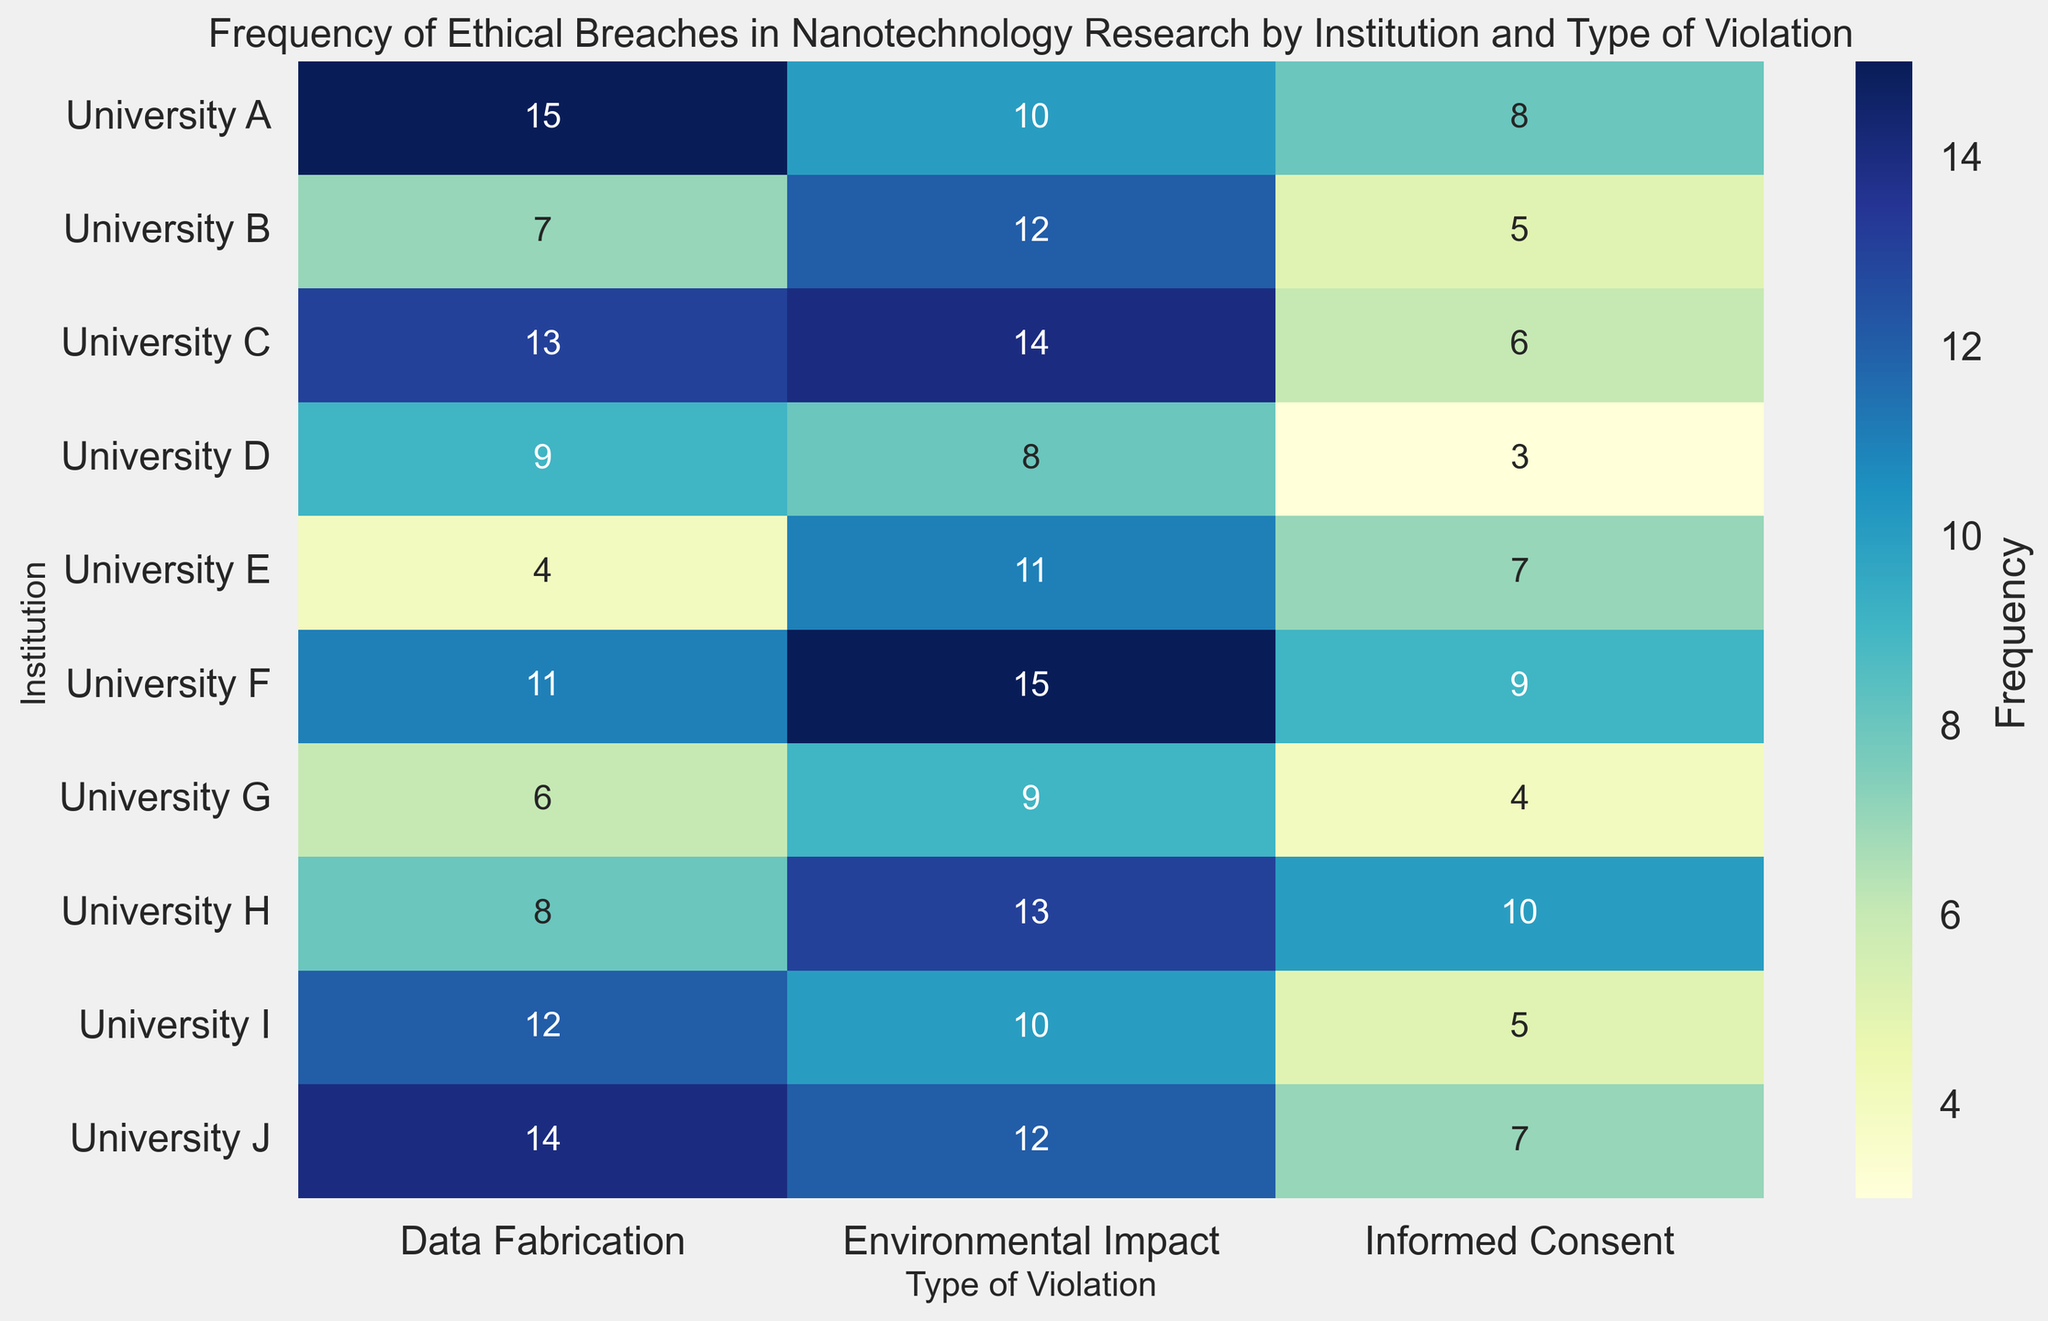What institution has the highest frequency of data fabrication violations? By observing the heatmap for the "Data Fabrication" column, the highest value can be seen in the row for University A, which corresponds to a frequency of 15.
Answer: University A Which institution has the lowest total frequency of ethical breaches? To determine this, we sum the frequencies of all types of violations for each institution. University E has the smallest total with 4 (Data Fabrication) + 7 (Informed Consent) + 11 (Environmental Impact) = 22.
Answer: University E What is the average frequency of environmental impact violations across all institutions? Sum the frequencies of environmental impact violations for all institutions, then divide by the number of institutions. The calculation is (10 + 12 + 14 + 8 + 11 + 15 + 9 + 13 + 10 + 12)/10 = 114/10 = 11.4.
Answer: 11.4 How does the frequency of informed consent violations at University H compare to University F? By checking the "Informed Consent" column, University H has a frequency of 10, while University F has a frequency of 9. Thus, University H has one more informed consent violation than University F.
Answer: University H has 1 more Which type of violation has the most variability across institutions? By comparing the color gradients (or values) in each column, the "Environmental Impact" column shows the most diverse values ranging from 8 to 15. This indicates a higher variability.
Answer: Environmental Impact How many institutions have more than 10 total violations of data fabrication and environmental impact combined? First sum the data fabrication and environmental impact frequencies for each institution: University A (25), University B (19), University C (27), University D (17), University E (15), University F (26), University G (15), University H (21), University I (22), University J (26). Institutions with >10 combined are: University A, University B, University C, University D, University F, University H, University I, University J. There are 8 such institutions.
Answer: 8 What is the most frequent type of violation overall? By summing the frequencies for each type of violation, the totals are: Data Fabrication (99), Informed Consent (64), Environmental Impact (114). Thus, Environmental Impact is the most frequent overall.
Answer: Environmental Impact 